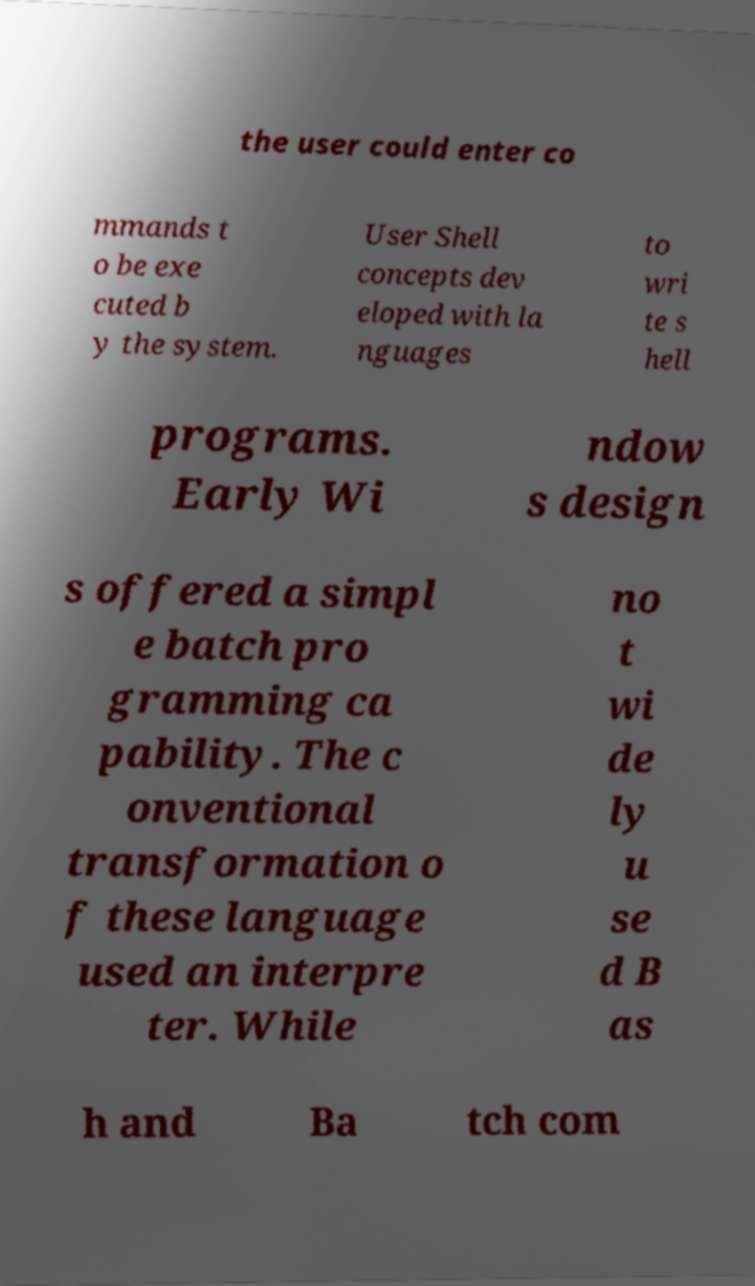Can you accurately transcribe the text from the provided image for me? the user could enter co mmands t o be exe cuted b y the system. User Shell concepts dev eloped with la nguages to wri te s hell programs. Early Wi ndow s design s offered a simpl e batch pro gramming ca pability. The c onventional transformation o f these language used an interpre ter. While no t wi de ly u se d B as h and Ba tch com 